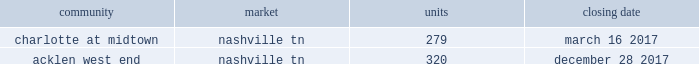2022 secondary market same store communities are generally communities in markets with populations of more than 1 million but less than 1% ( 1 % ) of the total public multifamily reit units or markets with populations of less than 1 million that we have owned and have been stabilized for at least a full 12 months .
2022 non-same store communities and other includes recent acquisitions , communities in development or lease-up , communities that have been identified for disposition , and communities that have undergone a significant casualty loss .
Also included in non-same store communities are non-multifamily activities .
On the first day of each calendar year , we determine the composition of our same store operating segments for that year as well as adjust the previous year , which allows us to evaluate full period-over-period operating comparisons .
An apartment community in development or lease-up is added to the same store portfolio on the first day of the calendar year after it has been owned and stabilized for at least a full 12 months .
Communities are considered stabilized after achieving 90% ( 90 % ) occupancy for 90 days .
Communities that have been identified for disposition are excluded from the same store portfolio .
All properties acquired from post properties in the merger remained in the non-same store and other operating segment during 2017 , as the properties were recent acquisitions and had not been owned and stabilized for at least 12 months as of january 1 , 2017 .
For additional information regarding our operating segments , see note 14 to the consolidated financial statements included elsewhere in this annual report on form 10-k .
Acquisitions one of our growth strategies is to acquire apartment communities that are located in various large or secondary markets primarily throughout the southeast and southwest regions of the united states .
Acquisitions , along with dispositions , help us achieve and maintain our desired product mix , geographic diversification and asset allocation .
Portfolio growth allows for maximizing the efficiency of the existing management and overhead structure .
We have extensive experience in the acquisition of multifamily communities .
We will continue to evaluate opportunities that arise , and we will utilize this strategy to increase our number of apartment communities in strong and growing markets .
We acquired the following apartment communities during the year ended december 31 , 2017: .
Dispositions we sell apartment communities and other assets that no longer meet our long-term strategy or when market conditions are favorable , and we redeploy the proceeds from those sales to acquire , develop and redevelop additional apartment communities and rebalance our portfolio across or within geographic regions .
Dispositions also allow us to realize a portion of the value created through our investments and provide additional liquidity .
We are then able to redeploy the net proceeds from our dispositions in lieu of raising additional capital .
In deciding to sell an apartment community , we consider current market conditions and generally solicit competing bids from unrelated parties for these individual assets , considering the sales price and other key terms of each proposal .
We also consider portfolio dispositions when such a structure is useful to maximize proceeds and efficiency of execution .
During the year ended december 31 , 2017 , we disposed of five multifamily properties totaling 1760 units and four land parcels totaling approximately 23 acres .
Development as another part of our growth strategy , we invest in a limited number of development projects .
Development activities may be conducted through wholly-owned affiliated companies or through joint ventures with unaffiliated parties .
Fixed price construction contracts are signed with unrelated parties to minimize construction risk .
We typically manage the leasing portion of the project as units become available for lease .
We may also engage in limited expansion development opportunities on existing communities in which we typically serve as the developer .
While we seek opportunistic new development investments offering attractive long-term investment returns , we intend to maintain a total development commitment that we consider modest in relation to our total balance sheet and investment portfolio .
During the year ended december 31 , 2017 , we incurred $ 170.1 million in development costs and completed 7 development projects. .
During the year ended december 31 , 2017 , what was the ratio of the units disposed to the units acquired? 
Rationale: for the year ended december 31 , 2017 , the company disposed of 2.94 units for each unit acquired
Computations: (1760 / (279 + 320))
Answer: 2.93823. 